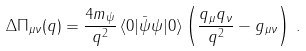Convert formula to latex. <formula><loc_0><loc_0><loc_500><loc_500>\Delta \Pi _ { \mu \nu } ( q ) = \frac { 4 m _ { \psi } } { q ^ { 2 } } \, \langle 0 | { \bar { \psi } } \psi | 0 \rangle \left ( \frac { q _ { \mu } q _ { \nu } } { q ^ { 2 } } - g _ { \mu \nu } \right ) \, .</formula> 